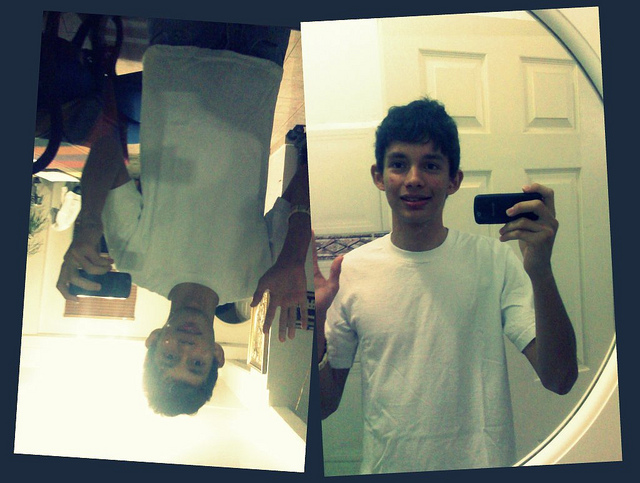If the person in the photo could speak, what would they say about their day? Hey! Today was pretty chill. I spent most of the day at home, and I tried experimenting with some selfie angles. This one with the mirror came out pretty cool, didn't it? It’s all about finding fun in the little things. Can't wait to share this with my friends! 